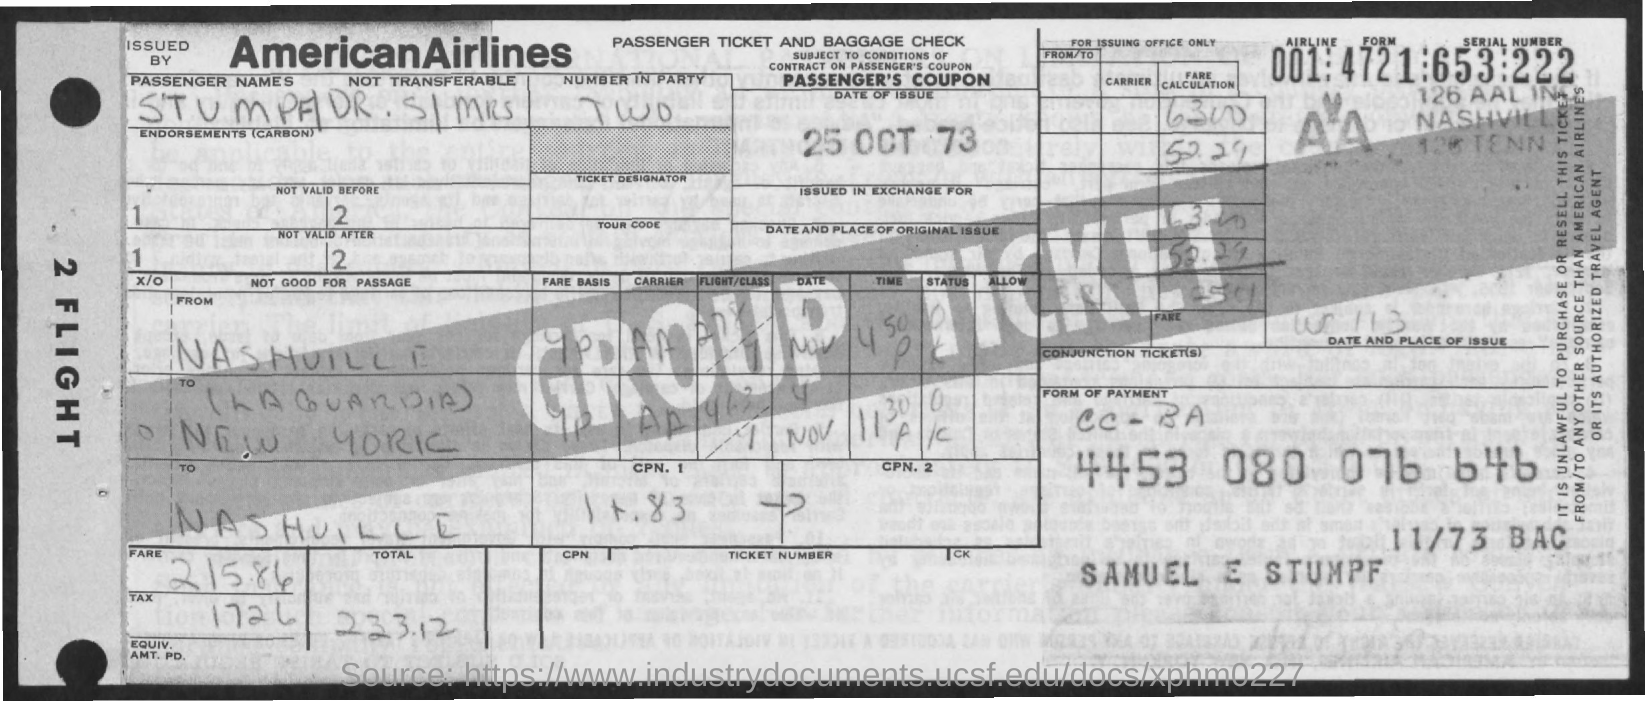What is the date of the issue?
Ensure brevity in your answer.  25 oct 73. What is the fare?
Offer a terse response. 215.86. What is the total?
Your answer should be compact. 233.12. What is the tax amount?
Keep it short and to the point. 172 6. 